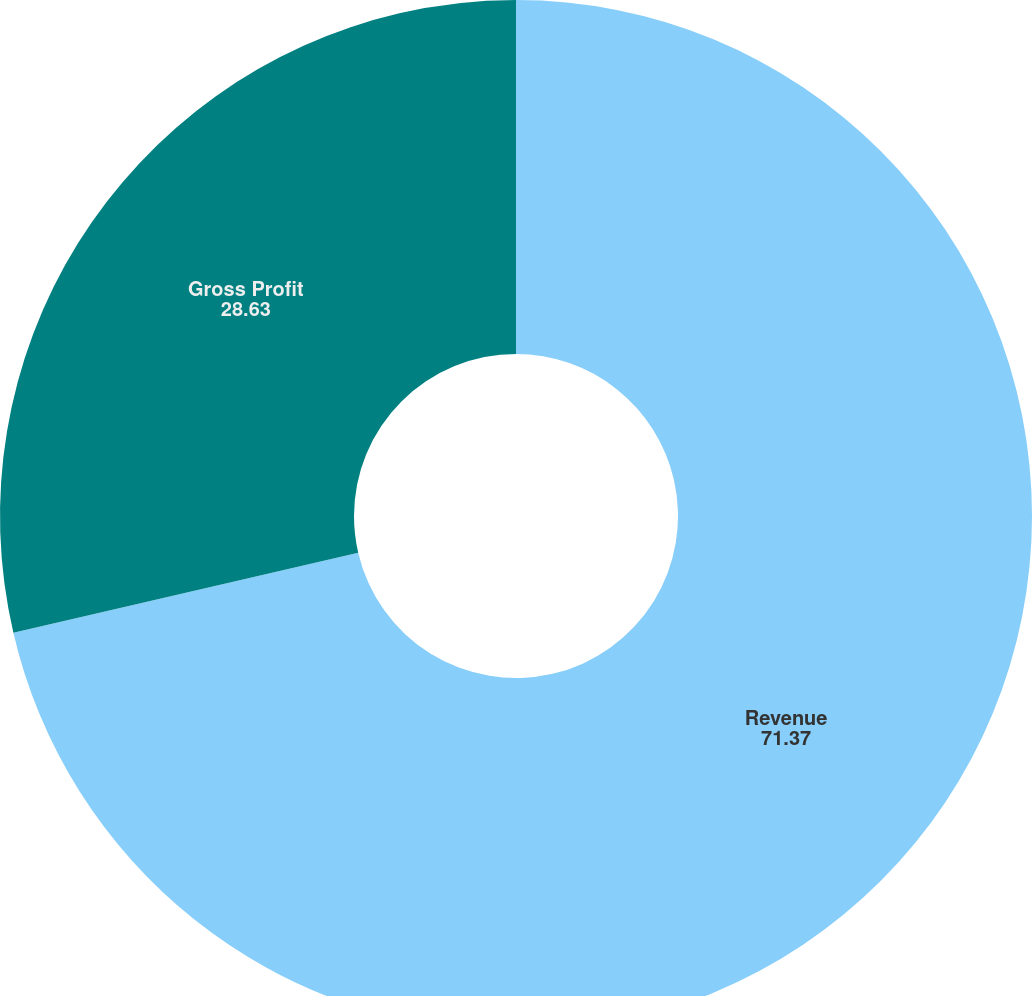<chart> <loc_0><loc_0><loc_500><loc_500><pie_chart><fcel>Revenue<fcel>Gross Profit<nl><fcel>71.37%<fcel>28.63%<nl></chart> 